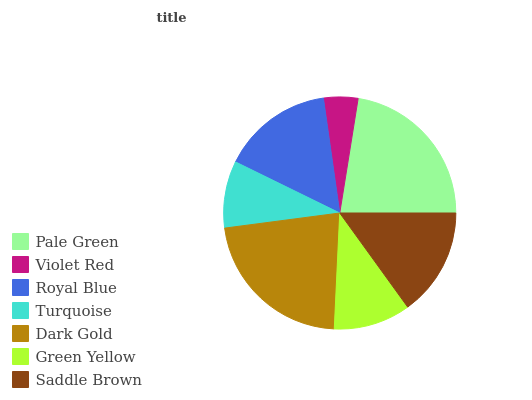Is Violet Red the minimum?
Answer yes or no. Yes. Is Pale Green the maximum?
Answer yes or no. Yes. Is Royal Blue the minimum?
Answer yes or no. No. Is Royal Blue the maximum?
Answer yes or no. No. Is Royal Blue greater than Violet Red?
Answer yes or no. Yes. Is Violet Red less than Royal Blue?
Answer yes or no. Yes. Is Violet Red greater than Royal Blue?
Answer yes or no. No. Is Royal Blue less than Violet Red?
Answer yes or no. No. Is Saddle Brown the high median?
Answer yes or no. Yes. Is Saddle Brown the low median?
Answer yes or no. Yes. Is Turquoise the high median?
Answer yes or no. No. Is Royal Blue the low median?
Answer yes or no. No. 